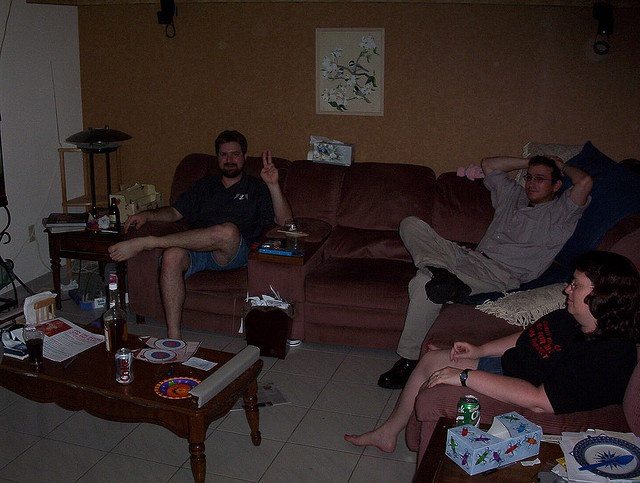Describe the objects in this image and their specific colors. I can see couch in black and gray tones, people in black, brown, and maroon tones, people in black tones, people in black, maroon, and brown tones, and couch in black, gray, and maroon tones in this image. 